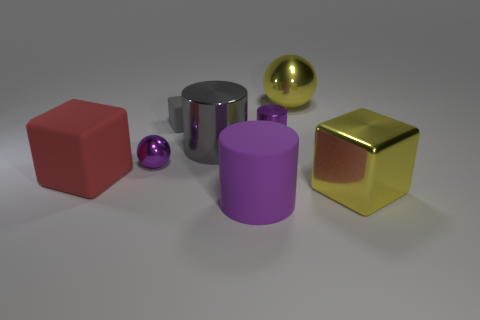There is a shiny thing that is the same color as the shiny cube; what is its shape?
Your answer should be compact. Sphere. Does the small gray thing have the same material as the tiny purple thing that is to the left of the gray metal cylinder?
Your answer should be very brief. No. There is a big object that is behind the tiny gray matte thing; what material is it?
Give a very brief answer. Metal. Is the number of red matte blocks behind the purple metal sphere the same as the number of cyan rubber cubes?
Your response must be concise. Yes. Is there anything else that has the same size as the gray rubber block?
Make the answer very short. Yes. There is a big object to the right of the yellow thing that is behind the small matte cube; what is it made of?
Your answer should be very brief. Metal. There is a large object that is right of the large matte cylinder and behind the big yellow cube; what shape is it?
Offer a terse response. Sphere. There is another metal thing that is the same shape as the small gray object; what size is it?
Provide a short and direct response. Large. Is the number of purple metallic objects behind the small purple shiny cylinder less than the number of large metallic blocks?
Ensure brevity in your answer.  Yes. What size is the cube that is behind the red thing?
Your answer should be very brief. Small. 